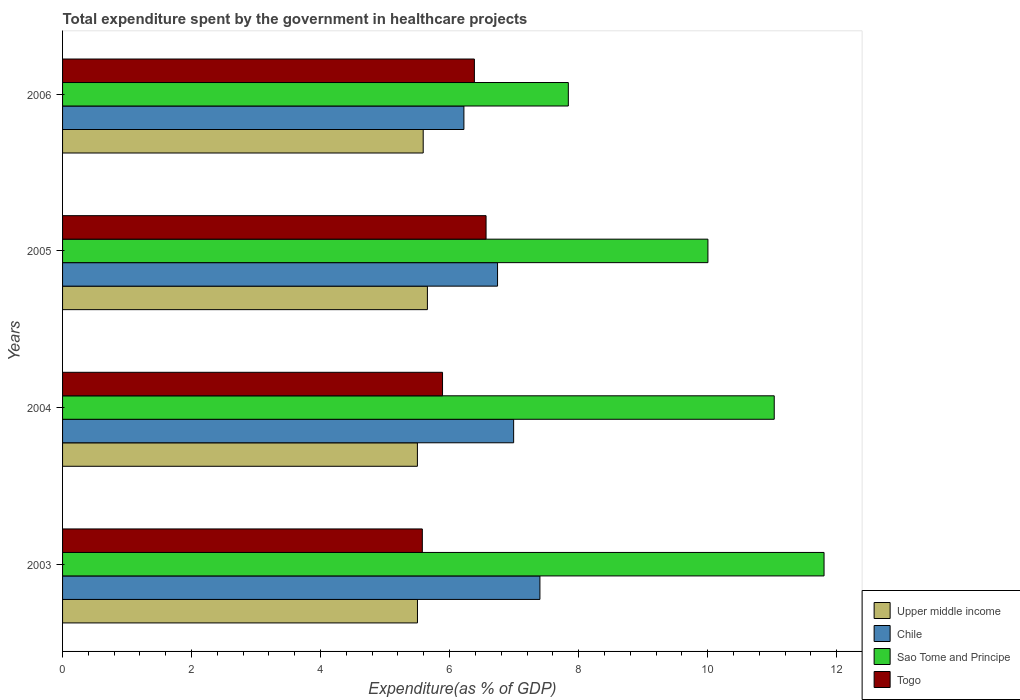How many different coloured bars are there?
Offer a terse response. 4. Are the number of bars on each tick of the Y-axis equal?
Your answer should be compact. Yes. How many bars are there on the 3rd tick from the top?
Make the answer very short. 4. In how many cases, is the number of bars for a given year not equal to the number of legend labels?
Give a very brief answer. 0. What is the total expenditure spent by the government in healthcare projects in Chile in 2003?
Keep it short and to the point. 7.4. Across all years, what is the maximum total expenditure spent by the government in healthcare projects in Chile?
Offer a very short reply. 7.4. Across all years, what is the minimum total expenditure spent by the government in healthcare projects in Sao Tome and Principe?
Ensure brevity in your answer.  7.84. In which year was the total expenditure spent by the government in healthcare projects in Togo minimum?
Offer a very short reply. 2003. What is the total total expenditure spent by the government in healthcare projects in Upper middle income in the graph?
Make the answer very short. 22.25. What is the difference between the total expenditure spent by the government in healthcare projects in Chile in 2003 and that in 2004?
Make the answer very short. 0.41. What is the difference between the total expenditure spent by the government in healthcare projects in Chile in 2006 and the total expenditure spent by the government in healthcare projects in Togo in 2003?
Give a very brief answer. 0.64. What is the average total expenditure spent by the government in healthcare projects in Chile per year?
Provide a succinct answer. 6.84. In the year 2004, what is the difference between the total expenditure spent by the government in healthcare projects in Upper middle income and total expenditure spent by the government in healthcare projects in Chile?
Provide a succinct answer. -1.49. What is the ratio of the total expenditure spent by the government in healthcare projects in Sao Tome and Principe in 2004 to that in 2005?
Provide a succinct answer. 1.1. Is the total expenditure spent by the government in healthcare projects in Sao Tome and Principe in 2004 less than that in 2006?
Offer a very short reply. No. What is the difference between the highest and the second highest total expenditure spent by the government in healthcare projects in Chile?
Your answer should be compact. 0.41. What is the difference between the highest and the lowest total expenditure spent by the government in healthcare projects in Chile?
Offer a terse response. 1.18. In how many years, is the total expenditure spent by the government in healthcare projects in Upper middle income greater than the average total expenditure spent by the government in healthcare projects in Upper middle income taken over all years?
Provide a succinct answer. 2. Is the sum of the total expenditure spent by the government in healthcare projects in Togo in 2005 and 2006 greater than the maximum total expenditure spent by the government in healthcare projects in Chile across all years?
Offer a very short reply. Yes. What does the 1st bar from the top in 2003 represents?
Provide a succinct answer. Togo. What does the 4th bar from the bottom in 2004 represents?
Your response must be concise. Togo. How many bars are there?
Give a very brief answer. 16. Are all the bars in the graph horizontal?
Offer a terse response. Yes. Does the graph contain grids?
Ensure brevity in your answer.  No. What is the title of the graph?
Your answer should be very brief. Total expenditure spent by the government in healthcare projects. Does "Senegal" appear as one of the legend labels in the graph?
Give a very brief answer. No. What is the label or title of the X-axis?
Give a very brief answer. Expenditure(as % of GDP). What is the Expenditure(as % of GDP) of Upper middle income in 2003?
Offer a terse response. 5.5. What is the Expenditure(as % of GDP) in Chile in 2003?
Provide a succinct answer. 7.4. What is the Expenditure(as % of GDP) in Sao Tome and Principe in 2003?
Provide a short and direct response. 11.81. What is the Expenditure(as % of GDP) in Togo in 2003?
Give a very brief answer. 5.58. What is the Expenditure(as % of GDP) in Upper middle income in 2004?
Make the answer very short. 5.5. What is the Expenditure(as % of GDP) of Chile in 2004?
Make the answer very short. 6.99. What is the Expenditure(as % of GDP) in Sao Tome and Principe in 2004?
Provide a succinct answer. 11.03. What is the Expenditure(as % of GDP) in Togo in 2004?
Provide a succinct answer. 5.89. What is the Expenditure(as % of GDP) of Upper middle income in 2005?
Your answer should be compact. 5.66. What is the Expenditure(as % of GDP) of Chile in 2005?
Give a very brief answer. 6.74. What is the Expenditure(as % of GDP) of Sao Tome and Principe in 2005?
Offer a very short reply. 10. What is the Expenditure(as % of GDP) in Togo in 2005?
Offer a terse response. 6.57. What is the Expenditure(as % of GDP) in Upper middle income in 2006?
Keep it short and to the point. 5.59. What is the Expenditure(as % of GDP) of Chile in 2006?
Provide a short and direct response. 6.22. What is the Expenditure(as % of GDP) of Sao Tome and Principe in 2006?
Ensure brevity in your answer.  7.84. What is the Expenditure(as % of GDP) in Togo in 2006?
Your answer should be very brief. 6.38. Across all years, what is the maximum Expenditure(as % of GDP) in Upper middle income?
Provide a succinct answer. 5.66. Across all years, what is the maximum Expenditure(as % of GDP) of Chile?
Your response must be concise. 7.4. Across all years, what is the maximum Expenditure(as % of GDP) of Sao Tome and Principe?
Provide a succinct answer. 11.81. Across all years, what is the maximum Expenditure(as % of GDP) in Togo?
Your answer should be compact. 6.57. Across all years, what is the minimum Expenditure(as % of GDP) in Upper middle income?
Offer a terse response. 5.5. Across all years, what is the minimum Expenditure(as % of GDP) in Chile?
Give a very brief answer. 6.22. Across all years, what is the minimum Expenditure(as % of GDP) of Sao Tome and Principe?
Your answer should be compact. 7.84. Across all years, what is the minimum Expenditure(as % of GDP) in Togo?
Make the answer very short. 5.58. What is the total Expenditure(as % of GDP) in Upper middle income in the graph?
Give a very brief answer. 22.25. What is the total Expenditure(as % of GDP) in Chile in the graph?
Ensure brevity in your answer.  27.36. What is the total Expenditure(as % of GDP) in Sao Tome and Principe in the graph?
Your answer should be compact. 40.68. What is the total Expenditure(as % of GDP) in Togo in the graph?
Keep it short and to the point. 24.42. What is the difference between the Expenditure(as % of GDP) of Upper middle income in 2003 and that in 2004?
Give a very brief answer. 0. What is the difference between the Expenditure(as % of GDP) of Chile in 2003 and that in 2004?
Give a very brief answer. 0.41. What is the difference between the Expenditure(as % of GDP) in Sao Tome and Principe in 2003 and that in 2004?
Your answer should be compact. 0.77. What is the difference between the Expenditure(as % of GDP) of Togo in 2003 and that in 2004?
Provide a short and direct response. -0.31. What is the difference between the Expenditure(as % of GDP) in Upper middle income in 2003 and that in 2005?
Your response must be concise. -0.15. What is the difference between the Expenditure(as % of GDP) in Chile in 2003 and that in 2005?
Provide a short and direct response. 0.66. What is the difference between the Expenditure(as % of GDP) of Sao Tome and Principe in 2003 and that in 2005?
Provide a short and direct response. 1.8. What is the difference between the Expenditure(as % of GDP) in Togo in 2003 and that in 2005?
Provide a short and direct response. -0.99. What is the difference between the Expenditure(as % of GDP) of Upper middle income in 2003 and that in 2006?
Offer a very short reply. -0.09. What is the difference between the Expenditure(as % of GDP) in Chile in 2003 and that in 2006?
Ensure brevity in your answer.  1.18. What is the difference between the Expenditure(as % of GDP) of Sao Tome and Principe in 2003 and that in 2006?
Offer a terse response. 3.96. What is the difference between the Expenditure(as % of GDP) of Togo in 2003 and that in 2006?
Your response must be concise. -0.81. What is the difference between the Expenditure(as % of GDP) in Upper middle income in 2004 and that in 2005?
Give a very brief answer. -0.15. What is the difference between the Expenditure(as % of GDP) in Chile in 2004 and that in 2005?
Your answer should be very brief. 0.25. What is the difference between the Expenditure(as % of GDP) in Sao Tome and Principe in 2004 and that in 2005?
Your response must be concise. 1.03. What is the difference between the Expenditure(as % of GDP) of Togo in 2004 and that in 2005?
Keep it short and to the point. -0.68. What is the difference between the Expenditure(as % of GDP) in Upper middle income in 2004 and that in 2006?
Your answer should be very brief. -0.09. What is the difference between the Expenditure(as % of GDP) in Chile in 2004 and that in 2006?
Provide a succinct answer. 0.77. What is the difference between the Expenditure(as % of GDP) in Sao Tome and Principe in 2004 and that in 2006?
Ensure brevity in your answer.  3.19. What is the difference between the Expenditure(as % of GDP) in Togo in 2004 and that in 2006?
Offer a very short reply. -0.49. What is the difference between the Expenditure(as % of GDP) in Upper middle income in 2005 and that in 2006?
Give a very brief answer. 0.07. What is the difference between the Expenditure(as % of GDP) of Chile in 2005 and that in 2006?
Your answer should be compact. 0.52. What is the difference between the Expenditure(as % of GDP) in Sao Tome and Principe in 2005 and that in 2006?
Ensure brevity in your answer.  2.16. What is the difference between the Expenditure(as % of GDP) of Togo in 2005 and that in 2006?
Offer a terse response. 0.18. What is the difference between the Expenditure(as % of GDP) in Upper middle income in 2003 and the Expenditure(as % of GDP) in Chile in 2004?
Make the answer very short. -1.49. What is the difference between the Expenditure(as % of GDP) of Upper middle income in 2003 and the Expenditure(as % of GDP) of Sao Tome and Principe in 2004?
Your answer should be very brief. -5.53. What is the difference between the Expenditure(as % of GDP) of Upper middle income in 2003 and the Expenditure(as % of GDP) of Togo in 2004?
Offer a very short reply. -0.39. What is the difference between the Expenditure(as % of GDP) of Chile in 2003 and the Expenditure(as % of GDP) of Sao Tome and Principe in 2004?
Provide a succinct answer. -3.63. What is the difference between the Expenditure(as % of GDP) of Chile in 2003 and the Expenditure(as % of GDP) of Togo in 2004?
Provide a succinct answer. 1.51. What is the difference between the Expenditure(as % of GDP) in Sao Tome and Principe in 2003 and the Expenditure(as % of GDP) in Togo in 2004?
Your response must be concise. 5.91. What is the difference between the Expenditure(as % of GDP) in Upper middle income in 2003 and the Expenditure(as % of GDP) in Chile in 2005?
Offer a terse response. -1.24. What is the difference between the Expenditure(as % of GDP) of Upper middle income in 2003 and the Expenditure(as % of GDP) of Sao Tome and Principe in 2005?
Ensure brevity in your answer.  -4.5. What is the difference between the Expenditure(as % of GDP) in Upper middle income in 2003 and the Expenditure(as % of GDP) in Togo in 2005?
Provide a short and direct response. -1.06. What is the difference between the Expenditure(as % of GDP) of Chile in 2003 and the Expenditure(as % of GDP) of Sao Tome and Principe in 2005?
Your answer should be compact. -2.6. What is the difference between the Expenditure(as % of GDP) of Chile in 2003 and the Expenditure(as % of GDP) of Togo in 2005?
Give a very brief answer. 0.83. What is the difference between the Expenditure(as % of GDP) in Sao Tome and Principe in 2003 and the Expenditure(as % of GDP) in Togo in 2005?
Keep it short and to the point. 5.24. What is the difference between the Expenditure(as % of GDP) of Upper middle income in 2003 and the Expenditure(as % of GDP) of Chile in 2006?
Your response must be concise. -0.72. What is the difference between the Expenditure(as % of GDP) of Upper middle income in 2003 and the Expenditure(as % of GDP) of Sao Tome and Principe in 2006?
Make the answer very short. -2.34. What is the difference between the Expenditure(as % of GDP) of Upper middle income in 2003 and the Expenditure(as % of GDP) of Togo in 2006?
Your response must be concise. -0.88. What is the difference between the Expenditure(as % of GDP) in Chile in 2003 and the Expenditure(as % of GDP) in Sao Tome and Principe in 2006?
Your answer should be compact. -0.44. What is the difference between the Expenditure(as % of GDP) of Sao Tome and Principe in 2003 and the Expenditure(as % of GDP) of Togo in 2006?
Provide a succinct answer. 5.42. What is the difference between the Expenditure(as % of GDP) in Upper middle income in 2004 and the Expenditure(as % of GDP) in Chile in 2005?
Keep it short and to the point. -1.24. What is the difference between the Expenditure(as % of GDP) of Upper middle income in 2004 and the Expenditure(as % of GDP) of Sao Tome and Principe in 2005?
Provide a short and direct response. -4.5. What is the difference between the Expenditure(as % of GDP) in Upper middle income in 2004 and the Expenditure(as % of GDP) in Togo in 2005?
Offer a very short reply. -1.06. What is the difference between the Expenditure(as % of GDP) of Chile in 2004 and the Expenditure(as % of GDP) of Sao Tome and Principe in 2005?
Offer a terse response. -3.01. What is the difference between the Expenditure(as % of GDP) in Chile in 2004 and the Expenditure(as % of GDP) in Togo in 2005?
Give a very brief answer. 0.43. What is the difference between the Expenditure(as % of GDP) in Sao Tome and Principe in 2004 and the Expenditure(as % of GDP) in Togo in 2005?
Provide a succinct answer. 4.47. What is the difference between the Expenditure(as % of GDP) in Upper middle income in 2004 and the Expenditure(as % of GDP) in Chile in 2006?
Provide a succinct answer. -0.72. What is the difference between the Expenditure(as % of GDP) in Upper middle income in 2004 and the Expenditure(as % of GDP) in Sao Tome and Principe in 2006?
Ensure brevity in your answer.  -2.34. What is the difference between the Expenditure(as % of GDP) of Upper middle income in 2004 and the Expenditure(as % of GDP) of Togo in 2006?
Ensure brevity in your answer.  -0.88. What is the difference between the Expenditure(as % of GDP) in Chile in 2004 and the Expenditure(as % of GDP) in Sao Tome and Principe in 2006?
Offer a very short reply. -0.85. What is the difference between the Expenditure(as % of GDP) in Chile in 2004 and the Expenditure(as % of GDP) in Togo in 2006?
Keep it short and to the point. 0.61. What is the difference between the Expenditure(as % of GDP) of Sao Tome and Principe in 2004 and the Expenditure(as % of GDP) of Togo in 2006?
Your answer should be compact. 4.65. What is the difference between the Expenditure(as % of GDP) of Upper middle income in 2005 and the Expenditure(as % of GDP) of Chile in 2006?
Your answer should be compact. -0.57. What is the difference between the Expenditure(as % of GDP) in Upper middle income in 2005 and the Expenditure(as % of GDP) in Sao Tome and Principe in 2006?
Ensure brevity in your answer.  -2.18. What is the difference between the Expenditure(as % of GDP) in Upper middle income in 2005 and the Expenditure(as % of GDP) in Togo in 2006?
Your answer should be compact. -0.73. What is the difference between the Expenditure(as % of GDP) in Chile in 2005 and the Expenditure(as % of GDP) in Sao Tome and Principe in 2006?
Keep it short and to the point. -1.1. What is the difference between the Expenditure(as % of GDP) of Chile in 2005 and the Expenditure(as % of GDP) of Togo in 2006?
Make the answer very short. 0.36. What is the difference between the Expenditure(as % of GDP) of Sao Tome and Principe in 2005 and the Expenditure(as % of GDP) of Togo in 2006?
Your answer should be compact. 3.62. What is the average Expenditure(as % of GDP) in Upper middle income per year?
Your answer should be very brief. 5.56. What is the average Expenditure(as % of GDP) of Chile per year?
Provide a succinct answer. 6.84. What is the average Expenditure(as % of GDP) of Sao Tome and Principe per year?
Provide a succinct answer. 10.17. What is the average Expenditure(as % of GDP) in Togo per year?
Your response must be concise. 6.1. In the year 2003, what is the difference between the Expenditure(as % of GDP) in Upper middle income and Expenditure(as % of GDP) in Chile?
Your response must be concise. -1.9. In the year 2003, what is the difference between the Expenditure(as % of GDP) of Upper middle income and Expenditure(as % of GDP) of Sao Tome and Principe?
Keep it short and to the point. -6.3. In the year 2003, what is the difference between the Expenditure(as % of GDP) of Upper middle income and Expenditure(as % of GDP) of Togo?
Give a very brief answer. -0.08. In the year 2003, what is the difference between the Expenditure(as % of GDP) of Chile and Expenditure(as % of GDP) of Sao Tome and Principe?
Offer a very short reply. -4.4. In the year 2003, what is the difference between the Expenditure(as % of GDP) of Chile and Expenditure(as % of GDP) of Togo?
Your response must be concise. 1.82. In the year 2003, what is the difference between the Expenditure(as % of GDP) in Sao Tome and Principe and Expenditure(as % of GDP) in Togo?
Keep it short and to the point. 6.23. In the year 2004, what is the difference between the Expenditure(as % of GDP) of Upper middle income and Expenditure(as % of GDP) of Chile?
Your answer should be very brief. -1.49. In the year 2004, what is the difference between the Expenditure(as % of GDP) of Upper middle income and Expenditure(as % of GDP) of Sao Tome and Principe?
Your answer should be compact. -5.53. In the year 2004, what is the difference between the Expenditure(as % of GDP) of Upper middle income and Expenditure(as % of GDP) of Togo?
Provide a succinct answer. -0.39. In the year 2004, what is the difference between the Expenditure(as % of GDP) of Chile and Expenditure(as % of GDP) of Sao Tome and Principe?
Keep it short and to the point. -4.04. In the year 2004, what is the difference between the Expenditure(as % of GDP) of Chile and Expenditure(as % of GDP) of Togo?
Your answer should be compact. 1.1. In the year 2004, what is the difference between the Expenditure(as % of GDP) in Sao Tome and Principe and Expenditure(as % of GDP) in Togo?
Provide a short and direct response. 5.14. In the year 2005, what is the difference between the Expenditure(as % of GDP) in Upper middle income and Expenditure(as % of GDP) in Chile?
Ensure brevity in your answer.  -1.09. In the year 2005, what is the difference between the Expenditure(as % of GDP) in Upper middle income and Expenditure(as % of GDP) in Sao Tome and Principe?
Provide a short and direct response. -4.35. In the year 2005, what is the difference between the Expenditure(as % of GDP) in Upper middle income and Expenditure(as % of GDP) in Togo?
Keep it short and to the point. -0.91. In the year 2005, what is the difference between the Expenditure(as % of GDP) of Chile and Expenditure(as % of GDP) of Sao Tome and Principe?
Provide a succinct answer. -3.26. In the year 2005, what is the difference between the Expenditure(as % of GDP) of Chile and Expenditure(as % of GDP) of Togo?
Your answer should be very brief. 0.18. In the year 2005, what is the difference between the Expenditure(as % of GDP) of Sao Tome and Principe and Expenditure(as % of GDP) of Togo?
Your answer should be compact. 3.44. In the year 2006, what is the difference between the Expenditure(as % of GDP) of Upper middle income and Expenditure(as % of GDP) of Chile?
Make the answer very short. -0.63. In the year 2006, what is the difference between the Expenditure(as % of GDP) of Upper middle income and Expenditure(as % of GDP) of Sao Tome and Principe?
Your answer should be compact. -2.25. In the year 2006, what is the difference between the Expenditure(as % of GDP) in Upper middle income and Expenditure(as % of GDP) in Togo?
Provide a short and direct response. -0.79. In the year 2006, what is the difference between the Expenditure(as % of GDP) of Chile and Expenditure(as % of GDP) of Sao Tome and Principe?
Make the answer very short. -1.62. In the year 2006, what is the difference between the Expenditure(as % of GDP) in Chile and Expenditure(as % of GDP) in Togo?
Offer a terse response. -0.16. In the year 2006, what is the difference between the Expenditure(as % of GDP) in Sao Tome and Principe and Expenditure(as % of GDP) in Togo?
Make the answer very short. 1.46. What is the ratio of the Expenditure(as % of GDP) of Chile in 2003 to that in 2004?
Keep it short and to the point. 1.06. What is the ratio of the Expenditure(as % of GDP) in Sao Tome and Principe in 2003 to that in 2004?
Keep it short and to the point. 1.07. What is the ratio of the Expenditure(as % of GDP) in Togo in 2003 to that in 2004?
Your answer should be compact. 0.95. What is the ratio of the Expenditure(as % of GDP) in Upper middle income in 2003 to that in 2005?
Offer a very short reply. 0.97. What is the ratio of the Expenditure(as % of GDP) in Chile in 2003 to that in 2005?
Make the answer very short. 1.1. What is the ratio of the Expenditure(as % of GDP) in Sao Tome and Principe in 2003 to that in 2005?
Provide a succinct answer. 1.18. What is the ratio of the Expenditure(as % of GDP) in Togo in 2003 to that in 2005?
Provide a succinct answer. 0.85. What is the ratio of the Expenditure(as % of GDP) in Upper middle income in 2003 to that in 2006?
Provide a short and direct response. 0.98. What is the ratio of the Expenditure(as % of GDP) in Chile in 2003 to that in 2006?
Your response must be concise. 1.19. What is the ratio of the Expenditure(as % of GDP) in Sao Tome and Principe in 2003 to that in 2006?
Your answer should be very brief. 1.51. What is the ratio of the Expenditure(as % of GDP) of Togo in 2003 to that in 2006?
Ensure brevity in your answer.  0.87. What is the ratio of the Expenditure(as % of GDP) of Upper middle income in 2004 to that in 2005?
Your response must be concise. 0.97. What is the ratio of the Expenditure(as % of GDP) in Chile in 2004 to that in 2005?
Make the answer very short. 1.04. What is the ratio of the Expenditure(as % of GDP) in Sao Tome and Principe in 2004 to that in 2005?
Your answer should be very brief. 1.1. What is the ratio of the Expenditure(as % of GDP) in Togo in 2004 to that in 2005?
Your response must be concise. 0.9. What is the ratio of the Expenditure(as % of GDP) of Upper middle income in 2004 to that in 2006?
Give a very brief answer. 0.98. What is the ratio of the Expenditure(as % of GDP) in Chile in 2004 to that in 2006?
Provide a short and direct response. 1.12. What is the ratio of the Expenditure(as % of GDP) of Sao Tome and Principe in 2004 to that in 2006?
Make the answer very short. 1.41. What is the ratio of the Expenditure(as % of GDP) of Togo in 2004 to that in 2006?
Offer a very short reply. 0.92. What is the ratio of the Expenditure(as % of GDP) in Upper middle income in 2005 to that in 2006?
Offer a terse response. 1.01. What is the ratio of the Expenditure(as % of GDP) in Chile in 2005 to that in 2006?
Offer a terse response. 1.08. What is the ratio of the Expenditure(as % of GDP) in Sao Tome and Principe in 2005 to that in 2006?
Offer a very short reply. 1.28. What is the ratio of the Expenditure(as % of GDP) of Togo in 2005 to that in 2006?
Your answer should be very brief. 1.03. What is the difference between the highest and the second highest Expenditure(as % of GDP) in Upper middle income?
Your response must be concise. 0.07. What is the difference between the highest and the second highest Expenditure(as % of GDP) in Chile?
Offer a very short reply. 0.41. What is the difference between the highest and the second highest Expenditure(as % of GDP) of Sao Tome and Principe?
Your answer should be very brief. 0.77. What is the difference between the highest and the second highest Expenditure(as % of GDP) of Togo?
Your response must be concise. 0.18. What is the difference between the highest and the lowest Expenditure(as % of GDP) of Upper middle income?
Make the answer very short. 0.15. What is the difference between the highest and the lowest Expenditure(as % of GDP) of Chile?
Give a very brief answer. 1.18. What is the difference between the highest and the lowest Expenditure(as % of GDP) of Sao Tome and Principe?
Your response must be concise. 3.96. What is the difference between the highest and the lowest Expenditure(as % of GDP) of Togo?
Provide a succinct answer. 0.99. 